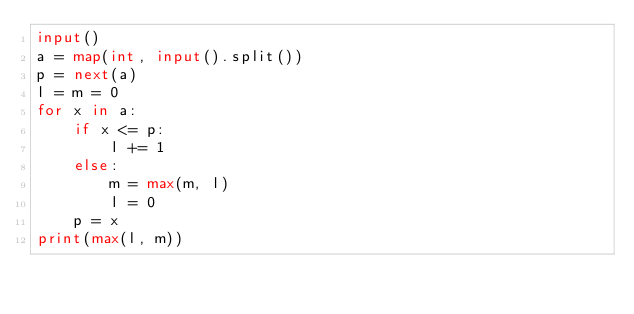Convert code to text. <code><loc_0><loc_0><loc_500><loc_500><_Python_>input()
a = map(int, input().split())
p = next(a)
l = m = 0
for x in a:
    if x <= p:
        l += 1
    else:
        m = max(m, l)
        l = 0
    p = x
print(max(l, m))
</code> 